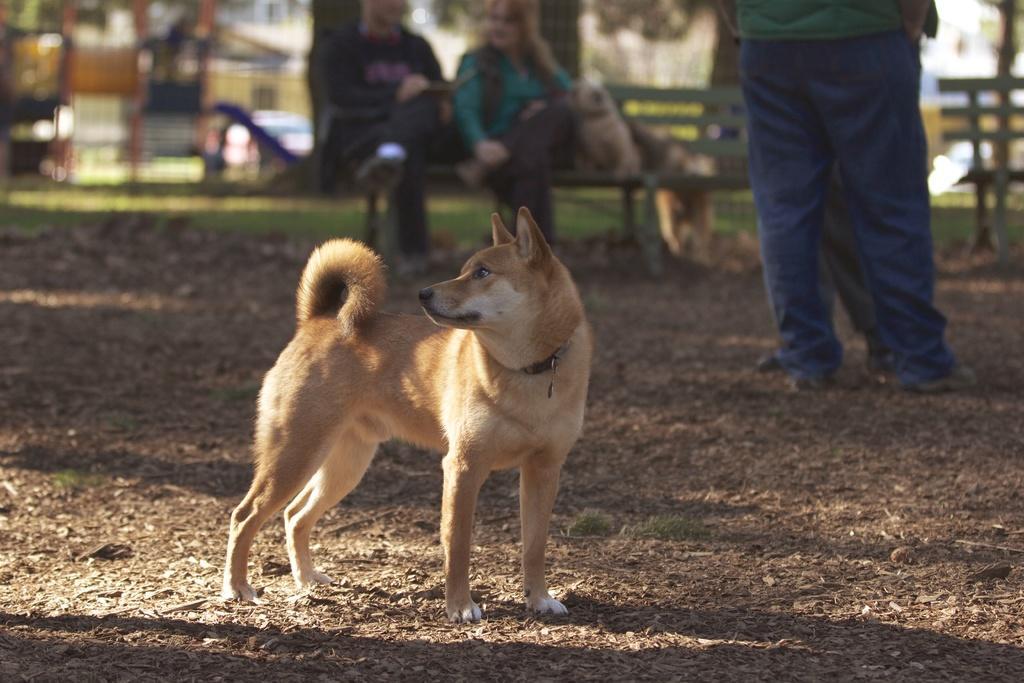Describe this image in one or two sentences. In this picture we can see a dog and two persons standing on the ground and in the background we can see two persons sitting on a bench, trees, car and it is blur. 